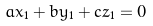<formula> <loc_0><loc_0><loc_500><loc_500>a x _ { 1 } + b y _ { 1 } + c z _ { 1 } = 0</formula> 